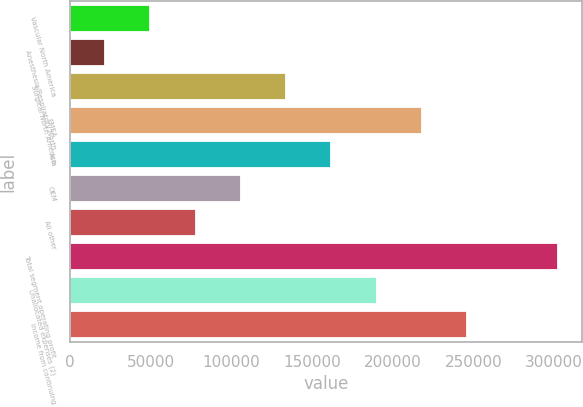Convert chart to OTSL. <chart><loc_0><loc_0><loc_500><loc_500><bar_chart><fcel>Vascular North America<fcel>Anesthesia/Respiratory North<fcel>Surgical North America<fcel>EMEA<fcel>Asia<fcel>OEM<fcel>All other<fcel>Total segment operating profit<fcel>Unallocated expenses (2)<fcel>Income from continuing<nl><fcel>49947.5<fcel>21910<fcel>134060<fcel>218172<fcel>162098<fcel>106022<fcel>77985<fcel>302285<fcel>190135<fcel>246210<nl></chart> 